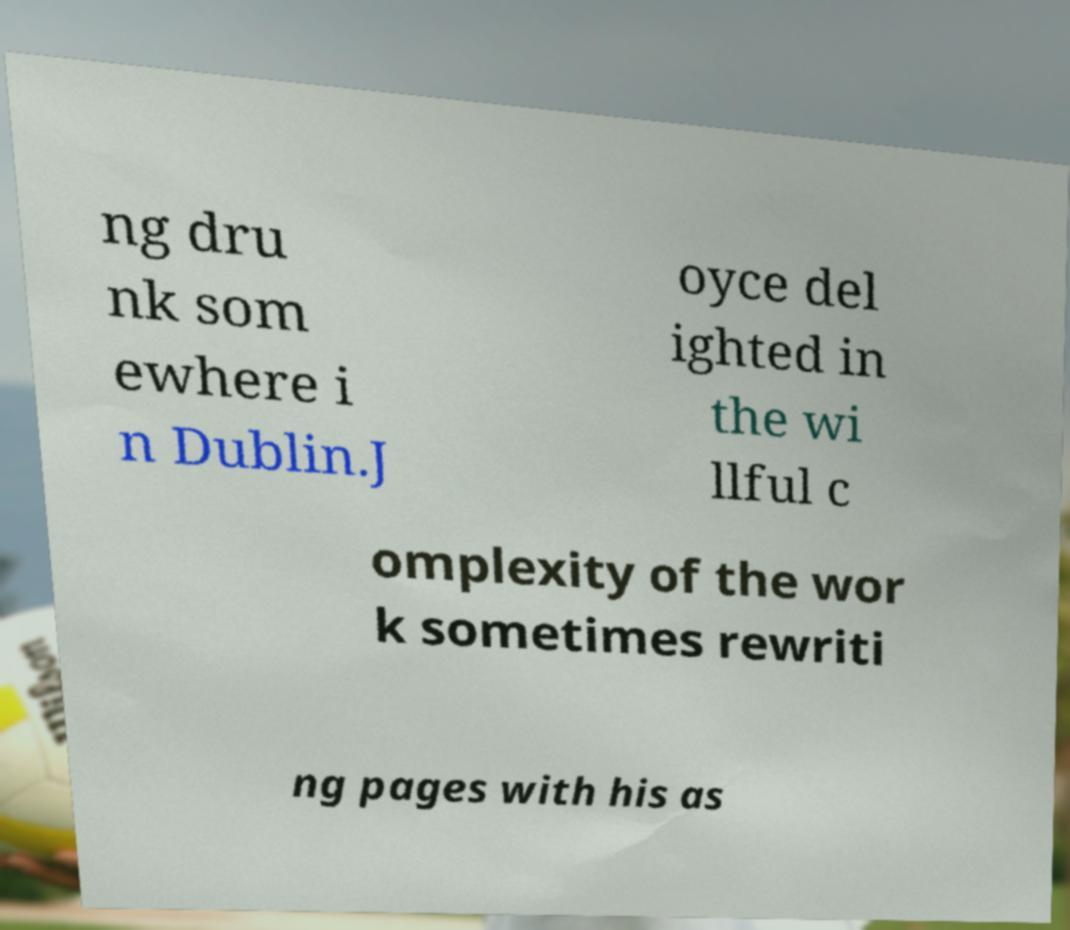What messages or text are displayed in this image? I need them in a readable, typed format. ng dru nk som ewhere i n Dublin.J oyce del ighted in the wi llful c omplexity of the wor k sometimes rewriti ng pages with his as 